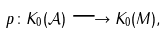Convert formula to latex. <formula><loc_0><loc_0><loc_500><loc_500>p \colon K _ { 0 } ( \mathcal { A } ) \longrightarrow K _ { 0 } ( M ) ,</formula> 